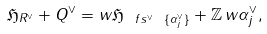<formula> <loc_0><loc_0><loc_500><loc_500>\mathfrak { H } _ { R ^ { \vee } } + Q ^ { \vee } = w \mathfrak { H } _ { \ f s ^ { \vee } \ \{ \alpha _ { j } ^ { \vee } \} } + \mathbb { Z } \, w \alpha _ { j } ^ { \vee } ,</formula> 